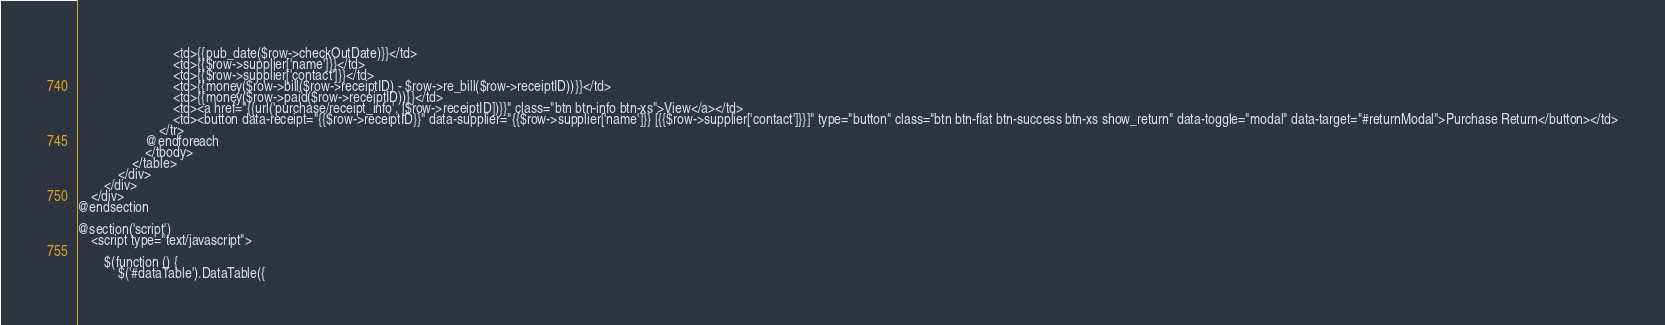Convert code to text. <code><loc_0><loc_0><loc_500><loc_500><_PHP_>                            <td>{{pub_date($row->checkOutDate)}}</td>
                            <td>{{$row->supplier['name']}}</td>
                            <td>{{$row->supplier['contact']}}</td>
                            <td>{{money($row->bill($row->receiptID) - $row->re_bill($row->receiptID))}}</td>
                            <td>{{money($row->paid($row->receiptID))}}</td>
                            <td><a href="{{url('purchase/receipt_info', [$row->receiptID])}}" class="btn btn-info btn-xs">View</a></td>
                            <td><button data-receipt="{{$row->receiptID}}" data-supplier="{{$row->supplier['name']}} [{{$row->supplier['contact']}}]" type="button" class="btn btn-flat btn-success btn-xs show_return" data-toggle="modal" data-target="#returnModal">Purchase Return</button></td>
                        </tr>
                    @endforeach
                    </tbody>
                </table>
            </div>
        </div>
    </div>
@endsection

@section('script')
    <script type="text/javascript">

        $(function () {
            $('#dataTable').DataTable({</code> 